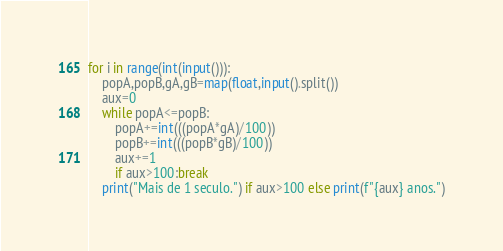Convert code to text. <code><loc_0><loc_0><loc_500><loc_500><_Python_>for i in range(int(input())):
    popA,popB,gA,gB=map(float,input().split())
    aux=0
    while popA<=popB:
        popA+=int(((popA*gA)/100))
        popB+=int(((popB*gB)/100))
        aux+=1
        if aux>100:break
    print("Mais de 1 seculo.") if aux>100 else print(f"{aux} anos.")
</code> 